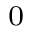<formula> <loc_0><loc_0><loc_500><loc_500>_ { 0 }</formula> 